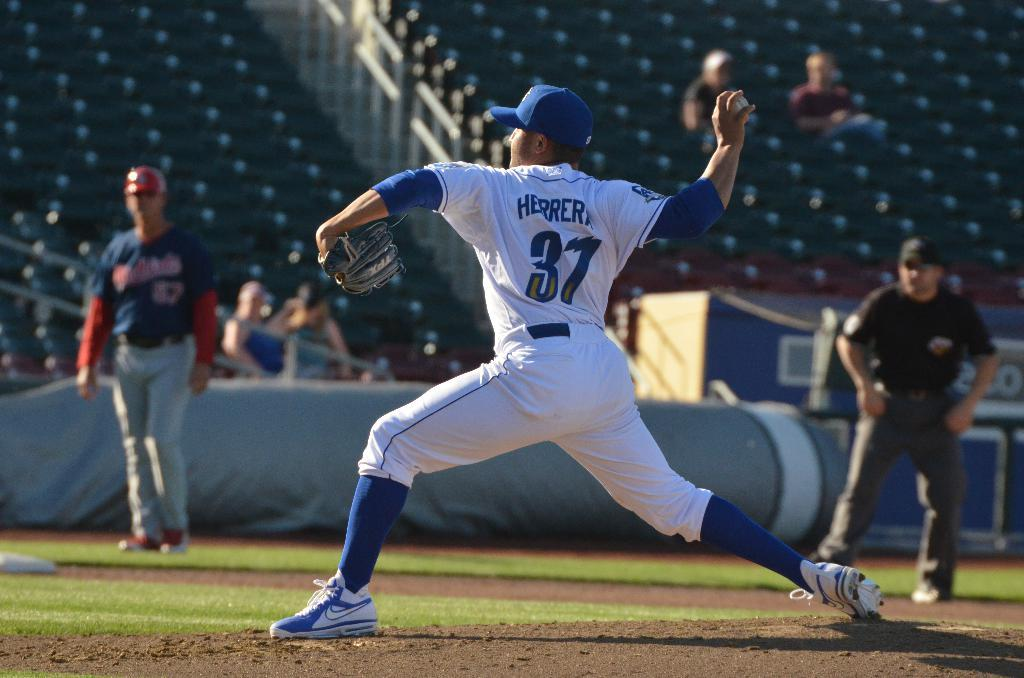<image>
Render a clear and concise summary of the photo. Herrera throwing a pitch for the baseball game with some fans looking on. 